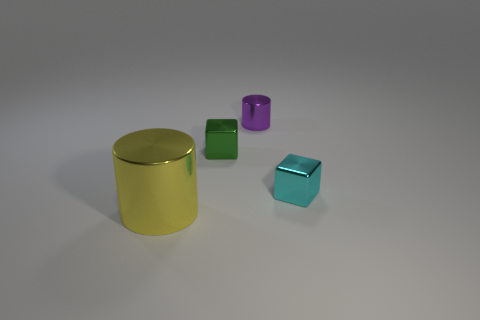Add 4 small red metallic spheres. How many objects exist? 8 Subtract all yellow cylinders. How many cylinders are left? 1 Add 1 large cyan rubber cylinders. How many large cyan rubber cylinders exist? 1 Subtract 0 purple balls. How many objects are left? 4 Subtract 1 blocks. How many blocks are left? 1 Subtract all purple cylinders. Subtract all brown spheres. How many cylinders are left? 1 Subtract all green spheres. How many green blocks are left? 1 Subtract all blocks. Subtract all large yellow things. How many objects are left? 1 Add 3 big yellow shiny things. How many big yellow shiny things are left? 4 